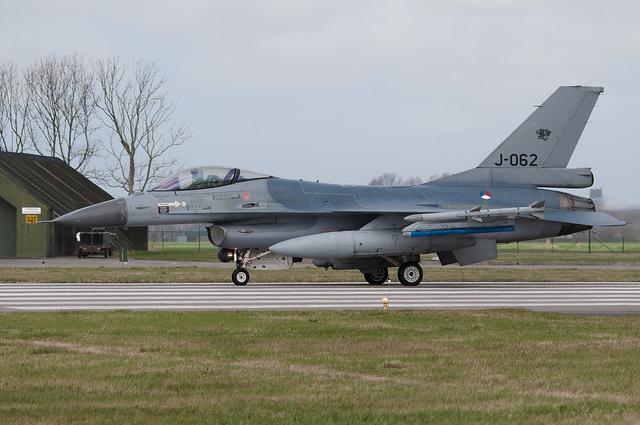What is the plane doing?
Concise answer only. Landing. How many wheels are on the ground?
Quick response, please. 3. Is the landing gear up or down?
Answer briefly. Down. Are there clouds?
Quick response, please. Yes. Is the jet taking off?
Be succinct. No. 